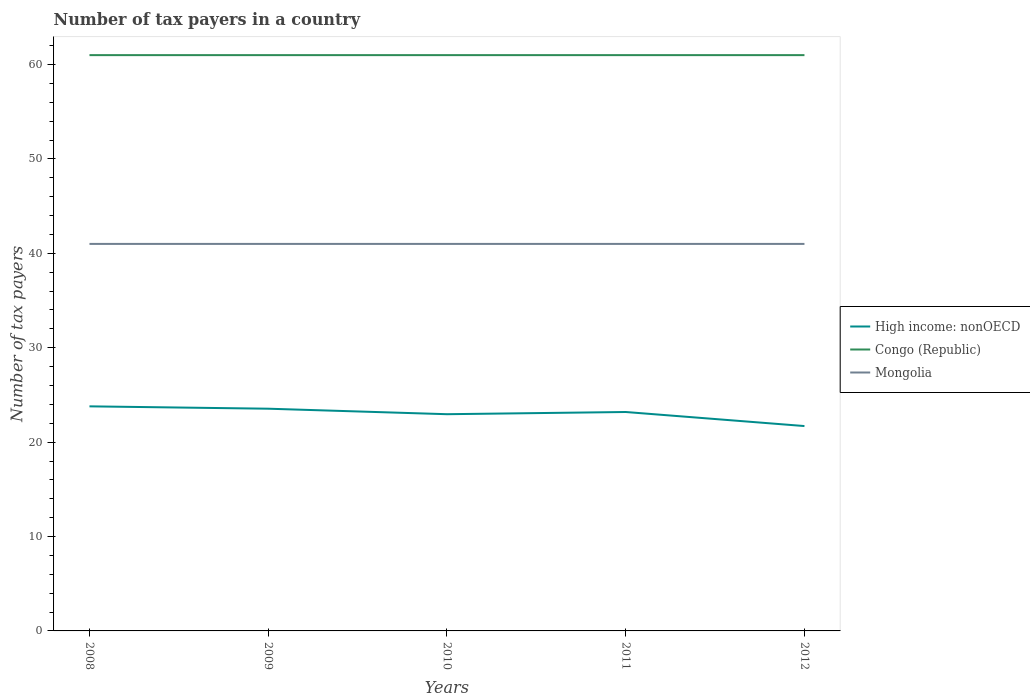Does the line corresponding to Mongolia intersect with the line corresponding to Congo (Republic)?
Offer a very short reply. No. Across all years, what is the maximum number of tax payers in in High income: nonOECD?
Give a very brief answer. 21.7. What is the difference between the highest and the second highest number of tax payers in in Mongolia?
Provide a short and direct response. 0. Is the number of tax payers in in High income: nonOECD strictly greater than the number of tax payers in in Congo (Republic) over the years?
Your answer should be compact. Yes. How many years are there in the graph?
Provide a succinct answer. 5. What is the difference between two consecutive major ticks on the Y-axis?
Offer a very short reply. 10. Are the values on the major ticks of Y-axis written in scientific E-notation?
Offer a terse response. No. Does the graph contain any zero values?
Your answer should be compact. No. Where does the legend appear in the graph?
Your answer should be very brief. Center right. What is the title of the graph?
Give a very brief answer. Number of tax payers in a country. Does "Netherlands" appear as one of the legend labels in the graph?
Your answer should be very brief. No. What is the label or title of the Y-axis?
Ensure brevity in your answer.  Number of tax payers. What is the Number of tax payers of High income: nonOECD in 2008?
Make the answer very short. 23.79. What is the Number of tax payers of Mongolia in 2008?
Make the answer very short. 41. What is the Number of tax payers of High income: nonOECD in 2009?
Offer a very short reply. 23.54. What is the Number of tax payers in Mongolia in 2009?
Provide a succinct answer. 41. What is the Number of tax payers in High income: nonOECD in 2010?
Offer a very short reply. 22.96. What is the Number of tax payers of High income: nonOECD in 2011?
Make the answer very short. 23.19. What is the Number of tax payers in Congo (Republic) in 2011?
Offer a terse response. 61. What is the Number of tax payers in High income: nonOECD in 2012?
Provide a short and direct response. 21.7. What is the Number of tax payers in Congo (Republic) in 2012?
Keep it short and to the point. 61. Across all years, what is the maximum Number of tax payers in High income: nonOECD?
Offer a very short reply. 23.79. Across all years, what is the maximum Number of tax payers in Congo (Republic)?
Ensure brevity in your answer.  61. Across all years, what is the maximum Number of tax payers in Mongolia?
Give a very brief answer. 41. Across all years, what is the minimum Number of tax payers in High income: nonOECD?
Your answer should be compact. 21.7. Across all years, what is the minimum Number of tax payers of Congo (Republic)?
Make the answer very short. 61. Across all years, what is the minimum Number of tax payers of Mongolia?
Provide a short and direct response. 41. What is the total Number of tax payers of High income: nonOECD in the graph?
Your answer should be very brief. 115.19. What is the total Number of tax payers in Congo (Republic) in the graph?
Keep it short and to the point. 305. What is the total Number of tax payers of Mongolia in the graph?
Offer a terse response. 205. What is the difference between the Number of tax payers in Congo (Republic) in 2008 and that in 2009?
Give a very brief answer. 0. What is the difference between the Number of tax payers of Mongolia in 2008 and that in 2009?
Provide a short and direct response. 0. What is the difference between the Number of tax payers in High income: nonOECD in 2008 and that in 2010?
Your response must be concise. 0.83. What is the difference between the Number of tax payers in High income: nonOECD in 2008 and that in 2011?
Provide a short and direct response. 0.6. What is the difference between the Number of tax payers in High income: nonOECD in 2008 and that in 2012?
Offer a terse response. 2.09. What is the difference between the Number of tax payers in Mongolia in 2008 and that in 2012?
Make the answer very short. 0. What is the difference between the Number of tax payers of High income: nonOECD in 2009 and that in 2010?
Make the answer very short. 0.58. What is the difference between the Number of tax payers of Congo (Republic) in 2009 and that in 2010?
Your answer should be compact. 0. What is the difference between the Number of tax payers of High income: nonOECD in 2009 and that in 2011?
Your response must be concise. 0.35. What is the difference between the Number of tax payers of High income: nonOECD in 2009 and that in 2012?
Offer a very short reply. 1.84. What is the difference between the Number of tax payers in Congo (Republic) in 2009 and that in 2012?
Make the answer very short. 0. What is the difference between the Number of tax payers in High income: nonOECD in 2010 and that in 2011?
Offer a very short reply. -0.23. What is the difference between the Number of tax payers of Congo (Republic) in 2010 and that in 2011?
Provide a succinct answer. 0. What is the difference between the Number of tax payers of High income: nonOECD in 2010 and that in 2012?
Keep it short and to the point. 1.25. What is the difference between the Number of tax payers in Mongolia in 2010 and that in 2012?
Your answer should be very brief. 0. What is the difference between the Number of tax payers in High income: nonOECD in 2011 and that in 2012?
Keep it short and to the point. 1.49. What is the difference between the Number of tax payers of Mongolia in 2011 and that in 2012?
Your answer should be compact. 0. What is the difference between the Number of tax payers in High income: nonOECD in 2008 and the Number of tax payers in Congo (Republic) in 2009?
Provide a short and direct response. -37.21. What is the difference between the Number of tax payers of High income: nonOECD in 2008 and the Number of tax payers of Mongolia in 2009?
Ensure brevity in your answer.  -17.21. What is the difference between the Number of tax payers of High income: nonOECD in 2008 and the Number of tax payers of Congo (Republic) in 2010?
Offer a terse response. -37.21. What is the difference between the Number of tax payers in High income: nonOECD in 2008 and the Number of tax payers in Mongolia in 2010?
Offer a very short reply. -17.21. What is the difference between the Number of tax payers in High income: nonOECD in 2008 and the Number of tax payers in Congo (Republic) in 2011?
Offer a very short reply. -37.21. What is the difference between the Number of tax payers in High income: nonOECD in 2008 and the Number of tax payers in Mongolia in 2011?
Offer a terse response. -17.21. What is the difference between the Number of tax payers of Congo (Republic) in 2008 and the Number of tax payers of Mongolia in 2011?
Keep it short and to the point. 20. What is the difference between the Number of tax payers in High income: nonOECD in 2008 and the Number of tax payers in Congo (Republic) in 2012?
Your response must be concise. -37.21. What is the difference between the Number of tax payers of High income: nonOECD in 2008 and the Number of tax payers of Mongolia in 2012?
Keep it short and to the point. -17.21. What is the difference between the Number of tax payers of Congo (Republic) in 2008 and the Number of tax payers of Mongolia in 2012?
Ensure brevity in your answer.  20. What is the difference between the Number of tax payers of High income: nonOECD in 2009 and the Number of tax payers of Congo (Republic) in 2010?
Your response must be concise. -37.46. What is the difference between the Number of tax payers of High income: nonOECD in 2009 and the Number of tax payers of Mongolia in 2010?
Ensure brevity in your answer.  -17.46. What is the difference between the Number of tax payers in High income: nonOECD in 2009 and the Number of tax payers in Congo (Republic) in 2011?
Make the answer very short. -37.46. What is the difference between the Number of tax payers of High income: nonOECD in 2009 and the Number of tax payers of Mongolia in 2011?
Offer a very short reply. -17.46. What is the difference between the Number of tax payers in High income: nonOECD in 2009 and the Number of tax payers in Congo (Republic) in 2012?
Ensure brevity in your answer.  -37.46. What is the difference between the Number of tax payers of High income: nonOECD in 2009 and the Number of tax payers of Mongolia in 2012?
Provide a short and direct response. -17.46. What is the difference between the Number of tax payers of High income: nonOECD in 2010 and the Number of tax payers of Congo (Republic) in 2011?
Your answer should be very brief. -38.04. What is the difference between the Number of tax payers in High income: nonOECD in 2010 and the Number of tax payers in Mongolia in 2011?
Offer a terse response. -18.04. What is the difference between the Number of tax payers of Congo (Republic) in 2010 and the Number of tax payers of Mongolia in 2011?
Give a very brief answer. 20. What is the difference between the Number of tax payers in High income: nonOECD in 2010 and the Number of tax payers in Congo (Republic) in 2012?
Offer a terse response. -38.04. What is the difference between the Number of tax payers in High income: nonOECD in 2010 and the Number of tax payers in Mongolia in 2012?
Make the answer very short. -18.04. What is the difference between the Number of tax payers of Congo (Republic) in 2010 and the Number of tax payers of Mongolia in 2012?
Offer a terse response. 20. What is the difference between the Number of tax payers in High income: nonOECD in 2011 and the Number of tax payers in Congo (Republic) in 2012?
Keep it short and to the point. -37.81. What is the difference between the Number of tax payers of High income: nonOECD in 2011 and the Number of tax payers of Mongolia in 2012?
Make the answer very short. -17.81. What is the average Number of tax payers of High income: nonOECD per year?
Give a very brief answer. 23.04. What is the average Number of tax payers in Mongolia per year?
Provide a short and direct response. 41. In the year 2008, what is the difference between the Number of tax payers in High income: nonOECD and Number of tax payers in Congo (Republic)?
Provide a succinct answer. -37.21. In the year 2008, what is the difference between the Number of tax payers in High income: nonOECD and Number of tax payers in Mongolia?
Ensure brevity in your answer.  -17.21. In the year 2008, what is the difference between the Number of tax payers of Congo (Republic) and Number of tax payers of Mongolia?
Your answer should be compact. 20. In the year 2009, what is the difference between the Number of tax payers in High income: nonOECD and Number of tax payers in Congo (Republic)?
Give a very brief answer. -37.46. In the year 2009, what is the difference between the Number of tax payers in High income: nonOECD and Number of tax payers in Mongolia?
Provide a succinct answer. -17.46. In the year 2009, what is the difference between the Number of tax payers of Congo (Republic) and Number of tax payers of Mongolia?
Offer a terse response. 20. In the year 2010, what is the difference between the Number of tax payers in High income: nonOECD and Number of tax payers in Congo (Republic)?
Your answer should be compact. -38.04. In the year 2010, what is the difference between the Number of tax payers of High income: nonOECD and Number of tax payers of Mongolia?
Your answer should be compact. -18.04. In the year 2011, what is the difference between the Number of tax payers of High income: nonOECD and Number of tax payers of Congo (Republic)?
Offer a very short reply. -37.81. In the year 2011, what is the difference between the Number of tax payers of High income: nonOECD and Number of tax payers of Mongolia?
Your answer should be very brief. -17.81. In the year 2011, what is the difference between the Number of tax payers of Congo (Republic) and Number of tax payers of Mongolia?
Make the answer very short. 20. In the year 2012, what is the difference between the Number of tax payers in High income: nonOECD and Number of tax payers in Congo (Republic)?
Make the answer very short. -39.3. In the year 2012, what is the difference between the Number of tax payers in High income: nonOECD and Number of tax payers in Mongolia?
Provide a succinct answer. -19.3. What is the ratio of the Number of tax payers of High income: nonOECD in 2008 to that in 2009?
Give a very brief answer. 1.01. What is the ratio of the Number of tax payers of Congo (Republic) in 2008 to that in 2009?
Give a very brief answer. 1. What is the ratio of the Number of tax payers of High income: nonOECD in 2008 to that in 2010?
Your response must be concise. 1.04. What is the ratio of the Number of tax payers in High income: nonOECD in 2008 to that in 2011?
Keep it short and to the point. 1.03. What is the ratio of the Number of tax payers in High income: nonOECD in 2008 to that in 2012?
Offer a very short reply. 1.1. What is the ratio of the Number of tax payers in Congo (Republic) in 2008 to that in 2012?
Keep it short and to the point. 1. What is the ratio of the Number of tax payers in High income: nonOECD in 2009 to that in 2010?
Your answer should be compact. 1.03. What is the ratio of the Number of tax payers of Mongolia in 2009 to that in 2010?
Keep it short and to the point. 1. What is the ratio of the Number of tax payers in High income: nonOECD in 2009 to that in 2011?
Keep it short and to the point. 1.02. What is the ratio of the Number of tax payers in Congo (Republic) in 2009 to that in 2011?
Provide a short and direct response. 1. What is the ratio of the Number of tax payers of High income: nonOECD in 2009 to that in 2012?
Your answer should be very brief. 1.08. What is the ratio of the Number of tax payers in Congo (Republic) in 2009 to that in 2012?
Offer a very short reply. 1. What is the ratio of the Number of tax payers of Mongolia in 2009 to that in 2012?
Offer a very short reply. 1. What is the ratio of the Number of tax payers of High income: nonOECD in 2010 to that in 2011?
Offer a terse response. 0.99. What is the ratio of the Number of tax payers of High income: nonOECD in 2010 to that in 2012?
Give a very brief answer. 1.06. What is the ratio of the Number of tax payers of Mongolia in 2010 to that in 2012?
Your answer should be very brief. 1. What is the ratio of the Number of tax payers in High income: nonOECD in 2011 to that in 2012?
Make the answer very short. 1.07. What is the ratio of the Number of tax payers in Congo (Republic) in 2011 to that in 2012?
Your answer should be very brief. 1. What is the ratio of the Number of tax payers of Mongolia in 2011 to that in 2012?
Offer a very short reply. 1. What is the difference between the highest and the second highest Number of tax payers of Congo (Republic)?
Provide a short and direct response. 0. What is the difference between the highest and the second highest Number of tax payers of Mongolia?
Offer a terse response. 0. What is the difference between the highest and the lowest Number of tax payers in High income: nonOECD?
Your answer should be very brief. 2.09. What is the difference between the highest and the lowest Number of tax payers of Mongolia?
Keep it short and to the point. 0. 